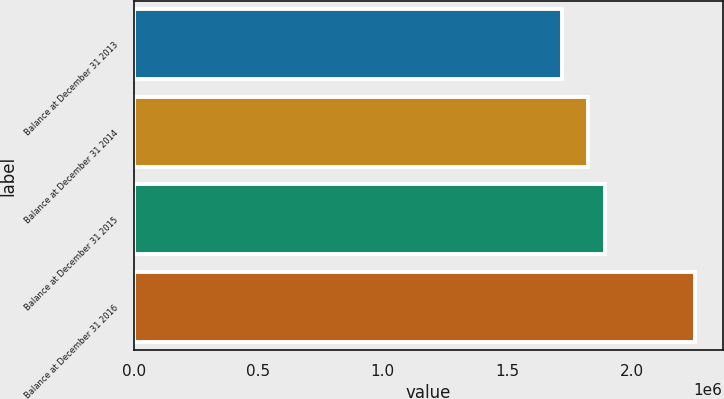Convert chart. <chart><loc_0><loc_0><loc_500><loc_500><bar_chart><fcel>Balance at December 31 2013<fcel>Balance at December 31 2014<fcel>Balance at December 31 2015<fcel>Balance at December 31 2016<nl><fcel>1.71972e+06<fcel>1.82424e+06<fcel>1.89166e+06<fcel>2.25332e+06<nl></chart> 